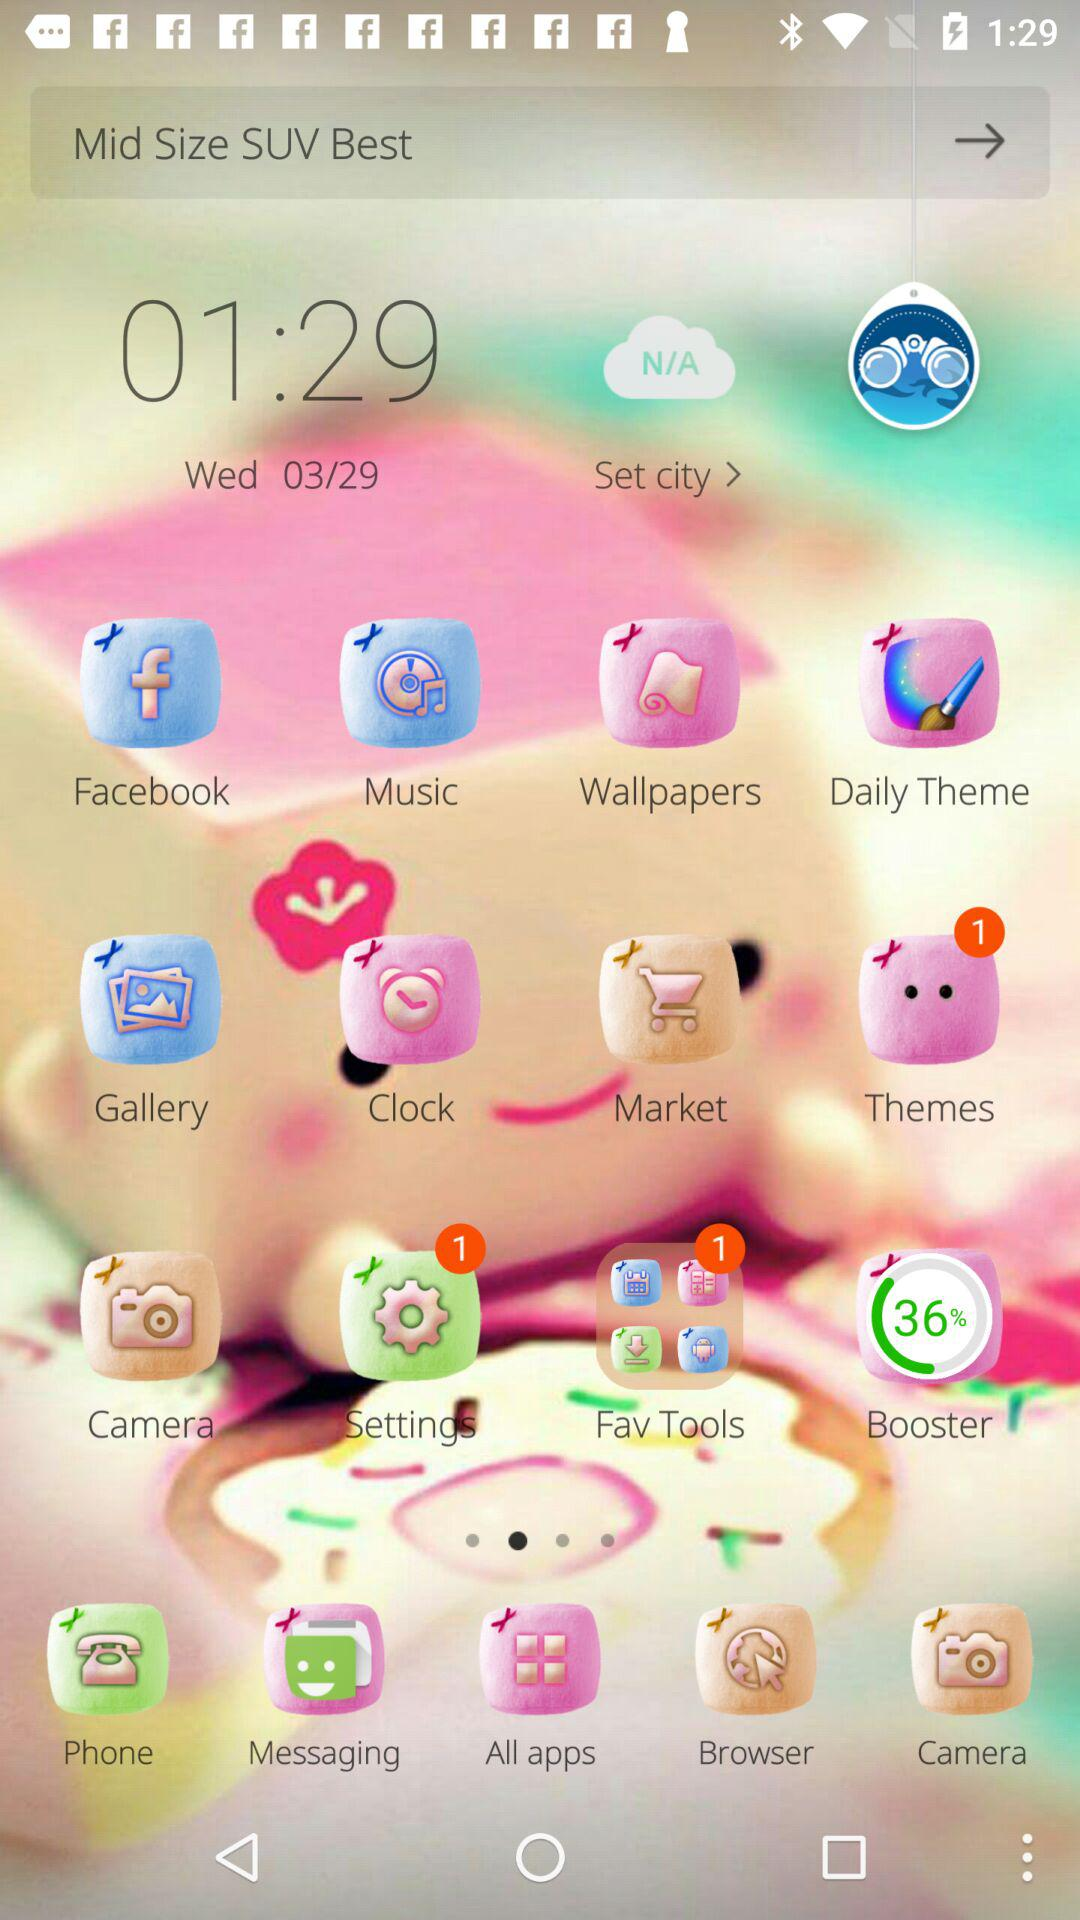Which mid-size SUV is the best?
When the provided information is insufficient, respond with <no answer>. <no answer> 